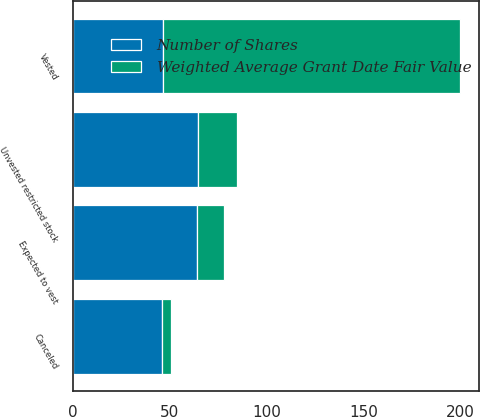<chart> <loc_0><loc_0><loc_500><loc_500><stacked_bar_chart><ecel><fcel>Unvested restricted stock<fcel>Vested<fcel>Canceled<fcel>Expected to vest<nl><fcel>Weighted Average Grant Date Fair Value<fcel>20<fcel>153<fcel>5<fcel>14<nl><fcel>Number of Shares<fcel>64.81<fcel>46.86<fcel>45.86<fcel>64<nl></chart> 